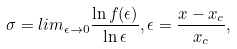<formula> <loc_0><loc_0><loc_500><loc_500>\sigma = l i m _ { \epsilon \rightarrow 0 } \frac { \ln f ( \epsilon ) } { \ln \epsilon } , \epsilon = \frac { x - x _ { c } } { x _ { c } } ,</formula> 